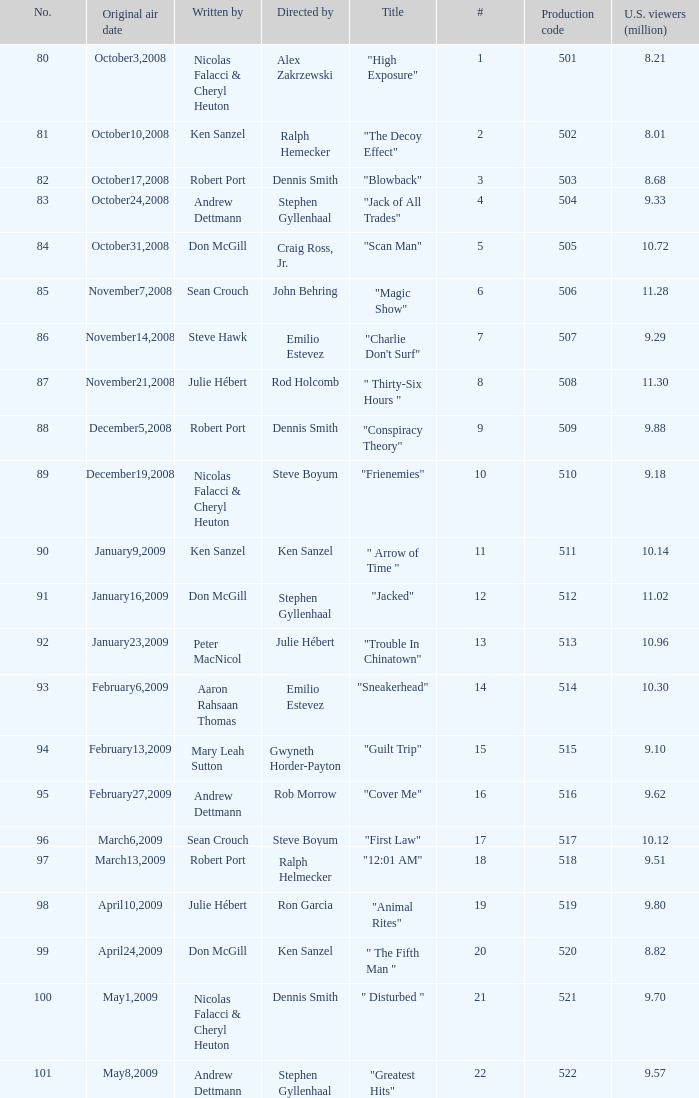What episode had 10.14 million viewers (U.S.)? 11.0. 